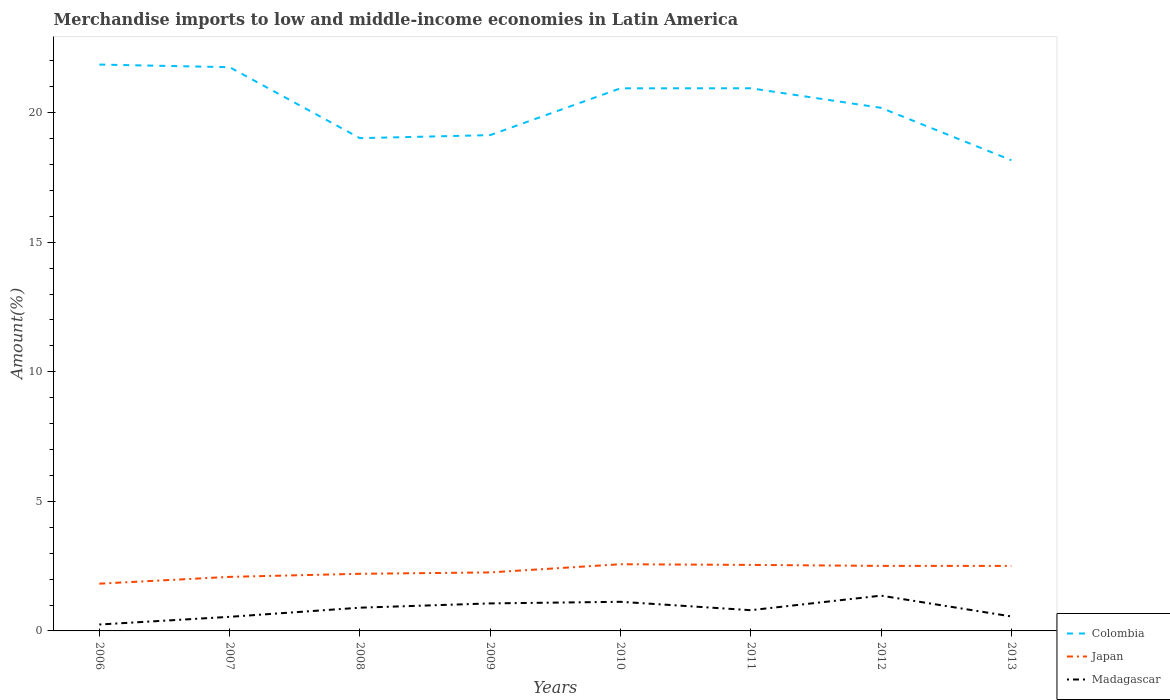Does the line corresponding to Japan intersect with the line corresponding to Madagascar?
Your response must be concise. No. Across all years, what is the maximum percentage of amount earned from merchandise imports in Japan?
Your answer should be compact. 1.82. In which year was the percentage of amount earned from merchandise imports in Colombia maximum?
Make the answer very short. 2013. What is the total percentage of amount earned from merchandise imports in Japan in the graph?
Provide a short and direct response. -0.38. What is the difference between the highest and the second highest percentage of amount earned from merchandise imports in Colombia?
Ensure brevity in your answer.  3.69. Is the percentage of amount earned from merchandise imports in Madagascar strictly greater than the percentage of amount earned from merchandise imports in Japan over the years?
Ensure brevity in your answer.  Yes. How many years are there in the graph?
Provide a short and direct response. 8. Does the graph contain any zero values?
Give a very brief answer. No. Does the graph contain grids?
Give a very brief answer. No. Where does the legend appear in the graph?
Give a very brief answer. Bottom right. How many legend labels are there?
Provide a short and direct response. 3. What is the title of the graph?
Your response must be concise. Merchandise imports to low and middle-income economies in Latin America. What is the label or title of the Y-axis?
Provide a succinct answer. Amount(%). What is the Amount(%) of Colombia in 2006?
Your response must be concise. 21.86. What is the Amount(%) of Japan in 2006?
Your answer should be very brief. 1.82. What is the Amount(%) in Madagascar in 2006?
Provide a short and direct response. 0.25. What is the Amount(%) of Colombia in 2007?
Your response must be concise. 21.76. What is the Amount(%) in Japan in 2007?
Provide a short and direct response. 2.09. What is the Amount(%) of Madagascar in 2007?
Offer a terse response. 0.54. What is the Amount(%) in Colombia in 2008?
Offer a terse response. 19.02. What is the Amount(%) in Japan in 2008?
Provide a succinct answer. 2.21. What is the Amount(%) in Madagascar in 2008?
Your answer should be very brief. 0.9. What is the Amount(%) of Colombia in 2009?
Provide a short and direct response. 19.14. What is the Amount(%) in Japan in 2009?
Offer a very short reply. 2.26. What is the Amount(%) in Madagascar in 2009?
Provide a short and direct response. 1.06. What is the Amount(%) of Colombia in 2010?
Make the answer very short. 20.94. What is the Amount(%) of Japan in 2010?
Keep it short and to the point. 2.57. What is the Amount(%) in Madagascar in 2010?
Offer a very short reply. 1.12. What is the Amount(%) in Colombia in 2011?
Offer a terse response. 20.94. What is the Amount(%) in Japan in 2011?
Your response must be concise. 2.55. What is the Amount(%) in Madagascar in 2011?
Give a very brief answer. 0.8. What is the Amount(%) of Colombia in 2012?
Your answer should be compact. 20.19. What is the Amount(%) in Japan in 2012?
Provide a short and direct response. 2.51. What is the Amount(%) in Madagascar in 2012?
Your response must be concise. 1.36. What is the Amount(%) of Colombia in 2013?
Your answer should be very brief. 18.17. What is the Amount(%) in Japan in 2013?
Keep it short and to the point. 2.51. What is the Amount(%) in Madagascar in 2013?
Offer a very short reply. 0.56. Across all years, what is the maximum Amount(%) in Colombia?
Offer a terse response. 21.86. Across all years, what is the maximum Amount(%) in Japan?
Give a very brief answer. 2.57. Across all years, what is the maximum Amount(%) of Madagascar?
Provide a short and direct response. 1.36. Across all years, what is the minimum Amount(%) in Colombia?
Make the answer very short. 18.17. Across all years, what is the minimum Amount(%) of Japan?
Make the answer very short. 1.82. Across all years, what is the minimum Amount(%) of Madagascar?
Ensure brevity in your answer.  0.25. What is the total Amount(%) in Colombia in the graph?
Your answer should be very brief. 162.01. What is the total Amount(%) in Japan in the graph?
Ensure brevity in your answer.  18.51. What is the total Amount(%) of Madagascar in the graph?
Give a very brief answer. 6.59. What is the difference between the Amount(%) of Colombia in 2006 and that in 2007?
Provide a succinct answer. 0.1. What is the difference between the Amount(%) of Japan in 2006 and that in 2007?
Offer a very short reply. -0.26. What is the difference between the Amount(%) of Madagascar in 2006 and that in 2007?
Offer a very short reply. -0.3. What is the difference between the Amount(%) in Colombia in 2006 and that in 2008?
Offer a terse response. 2.84. What is the difference between the Amount(%) in Japan in 2006 and that in 2008?
Offer a very short reply. -0.38. What is the difference between the Amount(%) of Madagascar in 2006 and that in 2008?
Your response must be concise. -0.65. What is the difference between the Amount(%) in Colombia in 2006 and that in 2009?
Give a very brief answer. 2.72. What is the difference between the Amount(%) of Japan in 2006 and that in 2009?
Give a very brief answer. -0.43. What is the difference between the Amount(%) of Madagascar in 2006 and that in 2009?
Offer a terse response. -0.81. What is the difference between the Amount(%) in Colombia in 2006 and that in 2010?
Your response must be concise. 0.92. What is the difference between the Amount(%) in Japan in 2006 and that in 2010?
Give a very brief answer. -0.75. What is the difference between the Amount(%) in Madagascar in 2006 and that in 2010?
Provide a short and direct response. -0.88. What is the difference between the Amount(%) of Colombia in 2006 and that in 2011?
Your answer should be very brief. 0.91. What is the difference between the Amount(%) in Japan in 2006 and that in 2011?
Your answer should be compact. -0.72. What is the difference between the Amount(%) in Madagascar in 2006 and that in 2011?
Provide a short and direct response. -0.55. What is the difference between the Amount(%) of Colombia in 2006 and that in 2012?
Offer a very short reply. 1.67. What is the difference between the Amount(%) of Japan in 2006 and that in 2012?
Offer a terse response. -0.69. What is the difference between the Amount(%) of Madagascar in 2006 and that in 2012?
Your answer should be very brief. -1.11. What is the difference between the Amount(%) in Colombia in 2006 and that in 2013?
Your answer should be compact. 3.69. What is the difference between the Amount(%) of Japan in 2006 and that in 2013?
Your response must be concise. -0.69. What is the difference between the Amount(%) in Madagascar in 2006 and that in 2013?
Offer a very short reply. -0.31. What is the difference between the Amount(%) of Colombia in 2007 and that in 2008?
Your answer should be very brief. 2.74. What is the difference between the Amount(%) of Japan in 2007 and that in 2008?
Your answer should be compact. -0.12. What is the difference between the Amount(%) in Madagascar in 2007 and that in 2008?
Make the answer very short. -0.35. What is the difference between the Amount(%) of Colombia in 2007 and that in 2009?
Your response must be concise. 2.62. What is the difference between the Amount(%) of Japan in 2007 and that in 2009?
Your answer should be compact. -0.17. What is the difference between the Amount(%) of Madagascar in 2007 and that in 2009?
Your answer should be very brief. -0.52. What is the difference between the Amount(%) in Colombia in 2007 and that in 2010?
Offer a terse response. 0.82. What is the difference between the Amount(%) of Japan in 2007 and that in 2010?
Keep it short and to the point. -0.49. What is the difference between the Amount(%) in Madagascar in 2007 and that in 2010?
Provide a succinct answer. -0.58. What is the difference between the Amount(%) of Colombia in 2007 and that in 2011?
Give a very brief answer. 0.81. What is the difference between the Amount(%) of Japan in 2007 and that in 2011?
Give a very brief answer. -0.46. What is the difference between the Amount(%) in Madagascar in 2007 and that in 2011?
Make the answer very short. -0.26. What is the difference between the Amount(%) in Colombia in 2007 and that in 2012?
Ensure brevity in your answer.  1.57. What is the difference between the Amount(%) in Japan in 2007 and that in 2012?
Your answer should be very brief. -0.42. What is the difference between the Amount(%) of Madagascar in 2007 and that in 2012?
Offer a terse response. -0.82. What is the difference between the Amount(%) in Colombia in 2007 and that in 2013?
Ensure brevity in your answer.  3.59. What is the difference between the Amount(%) in Japan in 2007 and that in 2013?
Offer a very short reply. -0.42. What is the difference between the Amount(%) of Madagascar in 2007 and that in 2013?
Provide a short and direct response. -0.02. What is the difference between the Amount(%) in Colombia in 2008 and that in 2009?
Offer a very short reply. -0.12. What is the difference between the Amount(%) in Japan in 2008 and that in 2009?
Make the answer very short. -0.05. What is the difference between the Amount(%) of Madagascar in 2008 and that in 2009?
Keep it short and to the point. -0.17. What is the difference between the Amount(%) of Colombia in 2008 and that in 2010?
Your answer should be very brief. -1.92. What is the difference between the Amount(%) of Japan in 2008 and that in 2010?
Make the answer very short. -0.37. What is the difference between the Amount(%) of Madagascar in 2008 and that in 2010?
Offer a terse response. -0.23. What is the difference between the Amount(%) of Colombia in 2008 and that in 2011?
Ensure brevity in your answer.  -1.93. What is the difference between the Amount(%) in Japan in 2008 and that in 2011?
Ensure brevity in your answer.  -0.34. What is the difference between the Amount(%) of Madagascar in 2008 and that in 2011?
Your response must be concise. 0.1. What is the difference between the Amount(%) in Colombia in 2008 and that in 2012?
Your answer should be compact. -1.17. What is the difference between the Amount(%) in Japan in 2008 and that in 2012?
Ensure brevity in your answer.  -0.3. What is the difference between the Amount(%) in Madagascar in 2008 and that in 2012?
Your answer should be compact. -0.46. What is the difference between the Amount(%) in Colombia in 2008 and that in 2013?
Make the answer very short. 0.85. What is the difference between the Amount(%) in Japan in 2008 and that in 2013?
Provide a succinct answer. -0.3. What is the difference between the Amount(%) of Madagascar in 2008 and that in 2013?
Provide a short and direct response. 0.34. What is the difference between the Amount(%) in Colombia in 2009 and that in 2010?
Offer a very short reply. -1.81. What is the difference between the Amount(%) of Japan in 2009 and that in 2010?
Your answer should be compact. -0.32. What is the difference between the Amount(%) of Madagascar in 2009 and that in 2010?
Provide a short and direct response. -0.06. What is the difference between the Amount(%) of Colombia in 2009 and that in 2011?
Offer a terse response. -1.81. What is the difference between the Amount(%) in Japan in 2009 and that in 2011?
Ensure brevity in your answer.  -0.29. What is the difference between the Amount(%) of Madagascar in 2009 and that in 2011?
Your answer should be compact. 0.26. What is the difference between the Amount(%) in Colombia in 2009 and that in 2012?
Make the answer very short. -1.05. What is the difference between the Amount(%) in Japan in 2009 and that in 2012?
Keep it short and to the point. -0.25. What is the difference between the Amount(%) of Madagascar in 2009 and that in 2012?
Your response must be concise. -0.3. What is the difference between the Amount(%) in Japan in 2009 and that in 2013?
Offer a very short reply. -0.25. What is the difference between the Amount(%) of Madagascar in 2009 and that in 2013?
Ensure brevity in your answer.  0.5. What is the difference between the Amount(%) of Colombia in 2010 and that in 2011?
Your response must be concise. -0. What is the difference between the Amount(%) of Japan in 2010 and that in 2011?
Give a very brief answer. 0.03. What is the difference between the Amount(%) in Madagascar in 2010 and that in 2011?
Your answer should be very brief. 0.32. What is the difference between the Amount(%) of Colombia in 2010 and that in 2012?
Provide a succinct answer. 0.75. What is the difference between the Amount(%) of Japan in 2010 and that in 2012?
Ensure brevity in your answer.  0.06. What is the difference between the Amount(%) in Madagascar in 2010 and that in 2012?
Give a very brief answer. -0.24. What is the difference between the Amount(%) of Colombia in 2010 and that in 2013?
Ensure brevity in your answer.  2.78. What is the difference between the Amount(%) of Japan in 2010 and that in 2013?
Your response must be concise. 0.06. What is the difference between the Amount(%) of Madagascar in 2010 and that in 2013?
Your answer should be very brief. 0.56. What is the difference between the Amount(%) of Colombia in 2011 and that in 2012?
Make the answer very short. 0.75. What is the difference between the Amount(%) in Japan in 2011 and that in 2012?
Give a very brief answer. 0.04. What is the difference between the Amount(%) in Madagascar in 2011 and that in 2012?
Provide a short and direct response. -0.56. What is the difference between the Amount(%) in Colombia in 2011 and that in 2013?
Ensure brevity in your answer.  2.78. What is the difference between the Amount(%) in Japan in 2011 and that in 2013?
Provide a short and direct response. 0.04. What is the difference between the Amount(%) in Madagascar in 2011 and that in 2013?
Provide a short and direct response. 0.24. What is the difference between the Amount(%) of Colombia in 2012 and that in 2013?
Provide a short and direct response. 2.02. What is the difference between the Amount(%) of Madagascar in 2012 and that in 2013?
Ensure brevity in your answer.  0.8. What is the difference between the Amount(%) of Colombia in 2006 and the Amount(%) of Japan in 2007?
Offer a very short reply. 19.77. What is the difference between the Amount(%) of Colombia in 2006 and the Amount(%) of Madagascar in 2007?
Give a very brief answer. 21.31. What is the difference between the Amount(%) of Japan in 2006 and the Amount(%) of Madagascar in 2007?
Keep it short and to the point. 1.28. What is the difference between the Amount(%) in Colombia in 2006 and the Amount(%) in Japan in 2008?
Make the answer very short. 19.65. What is the difference between the Amount(%) of Colombia in 2006 and the Amount(%) of Madagascar in 2008?
Provide a short and direct response. 20.96. What is the difference between the Amount(%) in Japan in 2006 and the Amount(%) in Madagascar in 2008?
Keep it short and to the point. 0.93. What is the difference between the Amount(%) of Colombia in 2006 and the Amount(%) of Japan in 2009?
Provide a short and direct response. 19.6. What is the difference between the Amount(%) of Colombia in 2006 and the Amount(%) of Madagascar in 2009?
Offer a terse response. 20.8. What is the difference between the Amount(%) of Japan in 2006 and the Amount(%) of Madagascar in 2009?
Your answer should be very brief. 0.76. What is the difference between the Amount(%) in Colombia in 2006 and the Amount(%) in Japan in 2010?
Keep it short and to the point. 19.28. What is the difference between the Amount(%) in Colombia in 2006 and the Amount(%) in Madagascar in 2010?
Make the answer very short. 20.73. What is the difference between the Amount(%) of Japan in 2006 and the Amount(%) of Madagascar in 2010?
Provide a succinct answer. 0.7. What is the difference between the Amount(%) in Colombia in 2006 and the Amount(%) in Japan in 2011?
Your answer should be very brief. 19.31. What is the difference between the Amount(%) of Colombia in 2006 and the Amount(%) of Madagascar in 2011?
Offer a terse response. 21.06. What is the difference between the Amount(%) of Japan in 2006 and the Amount(%) of Madagascar in 2011?
Your answer should be very brief. 1.02. What is the difference between the Amount(%) in Colombia in 2006 and the Amount(%) in Japan in 2012?
Your answer should be very brief. 19.35. What is the difference between the Amount(%) in Colombia in 2006 and the Amount(%) in Madagascar in 2012?
Offer a very short reply. 20.5. What is the difference between the Amount(%) in Japan in 2006 and the Amount(%) in Madagascar in 2012?
Make the answer very short. 0.46. What is the difference between the Amount(%) of Colombia in 2006 and the Amount(%) of Japan in 2013?
Give a very brief answer. 19.35. What is the difference between the Amount(%) in Colombia in 2006 and the Amount(%) in Madagascar in 2013?
Your answer should be very brief. 21.3. What is the difference between the Amount(%) of Japan in 2006 and the Amount(%) of Madagascar in 2013?
Provide a short and direct response. 1.26. What is the difference between the Amount(%) in Colombia in 2007 and the Amount(%) in Japan in 2008?
Your response must be concise. 19.55. What is the difference between the Amount(%) of Colombia in 2007 and the Amount(%) of Madagascar in 2008?
Provide a short and direct response. 20.86. What is the difference between the Amount(%) in Japan in 2007 and the Amount(%) in Madagascar in 2008?
Offer a terse response. 1.19. What is the difference between the Amount(%) of Colombia in 2007 and the Amount(%) of Japan in 2009?
Give a very brief answer. 19.5. What is the difference between the Amount(%) of Colombia in 2007 and the Amount(%) of Madagascar in 2009?
Ensure brevity in your answer.  20.7. What is the difference between the Amount(%) of Japan in 2007 and the Amount(%) of Madagascar in 2009?
Your response must be concise. 1.02. What is the difference between the Amount(%) in Colombia in 2007 and the Amount(%) in Japan in 2010?
Keep it short and to the point. 19.18. What is the difference between the Amount(%) in Colombia in 2007 and the Amount(%) in Madagascar in 2010?
Offer a terse response. 20.63. What is the difference between the Amount(%) of Japan in 2007 and the Amount(%) of Madagascar in 2010?
Offer a very short reply. 0.96. What is the difference between the Amount(%) of Colombia in 2007 and the Amount(%) of Japan in 2011?
Ensure brevity in your answer.  19.21. What is the difference between the Amount(%) in Colombia in 2007 and the Amount(%) in Madagascar in 2011?
Your response must be concise. 20.96. What is the difference between the Amount(%) of Japan in 2007 and the Amount(%) of Madagascar in 2011?
Keep it short and to the point. 1.29. What is the difference between the Amount(%) in Colombia in 2007 and the Amount(%) in Japan in 2012?
Give a very brief answer. 19.25. What is the difference between the Amount(%) of Colombia in 2007 and the Amount(%) of Madagascar in 2012?
Your answer should be very brief. 20.4. What is the difference between the Amount(%) in Japan in 2007 and the Amount(%) in Madagascar in 2012?
Your response must be concise. 0.72. What is the difference between the Amount(%) of Colombia in 2007 and the Amount(%) of Japan in 2013?
Your answer should be very brief. 19.25. What is the difference between the Amount(%) of Colombia in 2007 and the Amount(%) of Madagascar in 2013?
Your answer should be compact. 21.2. What is the difference between the Amount(%) in Japan in 2007 and the Amount(%) in Madagascar in 2013?
Keep it short and to the point. 1.53. What is the difference between the Amount(%) of Colombia in 2008 and the Amount(%) of Japan in 2009?
Your answer should be compact. 16.76. What is the difference between the Amount(%) of Colombia in 2008 and the Amount(%) of Madagascar in 2009?
Offer a very short reply. 17.96. What is the difference between the Amount(%) of Japan in 2008 and the Amount(%) of Madagascar in 2009?
Give a very brief answer. 1.14. What is the difference between the Amount(%) of Colombia in 2008 and the Amount(%) of Japan in 2010?
Ensure brevity in your answer.  16.44. What is the difference between the Amount(%) of Colombia in 2008 and the Amount(%) of Madagascar in 2010?
Offer a terse response. 17.89. What is the difference between the Amount(%) in Japan in 2008 and the Amount(%) in Madagascar in 2010?
Your answer should be very brief. 1.08. What is the difference between the Amount(%) of Colombia in 2008 and the Amount(%) of Japan in 2011?
Provide a short and direct response. 16.47. What is the difference between the Amount(%) in Colombia in 2008 and the Amount(%) in Madagascar in 2011?
Ensure brevity in your answer.  18.22. What is the difference between the Amount(%) in Japan in 2008 and the Amount(%) in Madagascar in 2011?
Ensure brevity in your answer.  1.41. What is the difference between the Amount(%) of Colombia in 2008 and the Amount(%) of Japan in 2012?
Offer a very short reply. 16.51. What is the difference between the Amount(%) in Colombia in 2008 and the Amount(%) in Madagascar in 2012?
Your response must be concise. 17.66. What is the difference between the Amount(%) in Japan in 2008 and the Amount(%) in Madagascar in 2012?
Your response must be concise. 0.84. What is the difference between the Amount(%) of Colombia in 2008 and the Amount(%) of Japan in 2013?
Offer a very short reply. 16.51. What is the difference between the Amount(%) in Colombia in 2008 and the Amount(%) in Madagascar in 2013?
Your answer should be very brief. 18.46. What is the difference between the Amount(%) of Japan in 2008 and the Amount(%) of Madagascar in 2013?
Keep it short and to the point. 1.65. What is the difference between the Amount(%) in Colombia in 2009 and the Amount(%) in Japan in 2010?
Your response must be concise. 16.56. What is the difference between the Amount(%) in Colombia in 2009 and the Amount(%) in Madagascar in 2010?
Make the answer very short. 18.01. What is the difference between the Amount(%) of Japan in 2009 and the Amount(%) of Madagascar in 2010?
Ensure brevity in your answer.  1.13. What is the difference between the Amount(%) of Colombia in 2009 and the Amount(%) of Japan in 2011?
Make the answer very short. 16.59. What is the difference between the Amount(%) in Colombia in 2009 and the Amount(%) in Madagascar in 2011?
Make the answer very short. 18.34. What is the difference between the Amount(%) of Japan in 2009 and the Amount(%) of Madagascar in 2011?
Provide a succinct answer. 1.46. What is the difference between the Amount(%) in Colombia in 2009 and the Amount(%) in Japan in 2012?
Your response must be concise. 16.63. What is the difference between the Amount(%) of Colombia in 2009 and the Amount(%) of Madagascar in 2012?
Provide a succinct answer. 17.77. What is the difference between the Amount(%) of Japan in 2009 and the Amount(%) of Madagascar in 2012?
Your answer should be very brief. 0.9. What is the difference between the Amount(%) in Colombia in 2009 and the Amount(%) in Japan in 2013?
Provide a succinct answer. 16.63. What is the difference between the Amount(%) in Colombia in 2009 and the Amount(%) in Madagascar in 2013?
Keep it short and to the point. 18.58. What is the difference between the Amount(%) of Japan in 2009 and the Amount(%) of Madagascar in 2013?
Offer a terse response. 1.7. What is the difference between the Amount(%) of Colombia in 2010 and the Amount(%) of Japan in 2011?
Offer a very short reply. 18.39. What is the difference between the Amount(%) in Colombia in 2010 and the Amount(%) in Madagascar in 2011?
Make the answer very short. 20.14. What is the difference between the Amount(%) in Japan in 2010 and the Amount(%) in Madagascar in 2011?
Make the answer very short. 1.77. What is the difference between the Amount(%) of Colombia in 2010 and the Amount(%) of Japan in 2012?
Ensure brevity in your answer.  18.43. What is the difference between the Amount(%) of Colombia in 2010 and the Amount(%) of Madagascar in 2012?
Keep it short and to the point. 19.58. What is the difference between the Amount(%) in Japan in 2010 and the Amount(%) in Madagascar in 2012?
Provide a short and direct response. 1.21. What is the difference between the Amount(%) in Colombia in 2010 and the Amount(%) in Japan in 2013?
Provide a succinct answer. 18.43. What is the difference between the Amount(%) in Colombia in 2010 and the Amount(%) in Madagascar in 2013?
Offer a very short reply. 20.38. What is the difference between the Amount(%) of Japan in 2010 and the Amount(%) of Madagascar in 2013?
Your response must be concise. 2.01. What is the difference between the Amount(%) of Colombia in 2011 and the Amount(%) of Japan in 2012?
Your answer should be very brief. 18.43. What is the difference between the Amount(%) in Colombia in 2011 and the Amount(%) in Madagascar in 2012?
Ensure brevity in your answer.  19.58. What is the difference between the Amount(%) of Japan in 2011 and the Amount(%) of Madagascar in 2012?
Keep it short and to the point. 1.19. What is the difference between the Amount(%) in Colombia in 2011 and the Amount(%) in Japan in 2013?
Offer a very short reply. 18.43. What is the difference between the Amount(%) in Colombia in 2011 and the Amount(%) in Madagascar in 2013?
Keep it short and to the point. 20.38. What is the difference between the Amount(%) of Japan in 2011 and the Amount(%) of Madagascar in 2013?
Ensure brevity in your answer.  1.99. What is the difference between the Amount(%) in Colombia in 2012 and the Amount(%) in Japan in 2013?
Offer a terse response. 17.68. What is the difference between the Amount(%) in Colombia in 2012 and the Amount(%) in Madagascar in 2013?
Your answer should be very brief. 19.63. What is the difference between the Amount(%) of Japan in 2012 and the Amount(%) of Madagascar in 2013?
Your answer should be very brief. 1.95. What is the average Amount(%) of Colombia per year?
Make the answer very short. 20.25. What is the average Amount(%) in Japan per year?
Provide a short and direct response. 2.31. What is the average Amount(%) in Madagascar per year?
Offer a terse response. 0.82. In the year 2006, what is the difference between the Amount(%) in Colombia and Amount(%) in Japan?
Give a very brief answer. 20.03. In the year 2006, what is the difference between the Amount(%) of Colombia and Amount(%) of Madagascar?
Your response must be concise. 21.61. In the year 2006, what is the difference between the Amount(%) in Japan and Amount(%) in Madagascar?
Give a very brief answer. 1.58. In the year 2007, what is the difference between the Amount(%) in Colombia and Amount(%) in Japan?
Your response must be concise. 19.67. In the year 2007, what is the difference between the Amount(%) of Colombia and Amount(%) of Madagascar?
Make the answer very short. 21.21. In the year 2007, what is the difference between the Amount(%) of Japan and Amount(%) of Madagascar?
Your answer should be compact. 1.54. In the year 2008, what is the difference between the Amount(%) of Colombia and Amount(%) of Japan?
Provide a succinct answer. 16.81. In the year 2008, what is the difference between the Amount(%) of Colombia and Amount(%) of Madagascar?
Your response must be concise. 18.12. In the year 2008, what is the difference between the Amount(%) of Japan and Amount(%) of Madagascar?
Give a very brief answer. 1.31. In the year 2009, what is the difference between the Amount(%) of Colombia and Amount(%) of Japan?
Keep it short and to the point. 16.88. In the year 2009, what is the difference between the Amount(%) in Colombia and Amount(%) in Madagascar?
Keep it short and to the point. 18.07. In the year 2009, what is the difference between the Amount(%) of Japan and Amount(%) of Madagascar?
Your response must be concise. 1.2. In the year 2010, what is the difference between the Amount(%) in Colombia and Amount(%) in Japan?
Give a very brief answer. 18.37. In the year 2010, what is the difference between the Amount(%) in Colombia and Amount(%) in Madagascar?
Give a very brief answer. 19.82. In the year 2010, what is the difference between the Amount(%) in Japan and Amount(%) in Madagascar?
Offer a terse response. 1.45. In the year 2011, what is the difference between the Amount(%) of Colombia and Amount(%) of Japan?
Your response must be concise. 18.39. In the year 2011, what is the difference between the Amount(%) in Colombia and Amount(%) in Madagascar?
Ensure brevity in your answer.  20.14. In the year 2011, what is the difference between the Amount(%) of Japan and Amount(%) of Madagascar?
Offer a very short reply. 1.75. In the year 2012, what is the difference between the Amount(%) of Colombia and Amount(%) of Japan?
Your response must be concise. 17.68. In the year 2012, what is the difference between the Amount(%) of Colombia and Amount(%) of Madagascar?
Your answer should be very brief. 18.83. In the year 2012, what is the difference between the Amount(%) in Japan and Amount(%) in Madagascar?
Keep it short and to the point. 1.15. In the year 2013, what is the difference between the Amount(%) of Colombia and Amount(%) of Japan?
Offer a terse response. 15.66. In the year 2013, what is the difference between the Amount(%) of Colombia and Amount(%) of Madagascar?
Provide a succinct answer. 17.61. In the year 2013, what is the difference between the Amount(%) in Japan and Amount(%) in Madagascar?
Provide a short and direct response. 1.95. What is the ratio of the Amount(%) in Japan in 2006 to that in 2007?
Ensure brevity in your answer.  0.87. What is the ratio of the Amount(%) in Madagascar in 2006 to that in 2007?
Your answer should be compact. 0.46. What is the ratio of the Amount(%) of Colombia in 2006 to that in 2008?
Give a very brief answer. 1.15. What is the ratio of the Amount(%) of Japan in 2006 to that in 2008?
Provide a short and direct response. 0.83. What is the ratio of the Amount(%) in Madagascar in 2006 to that in 2008?
Offer a very short reply. 0.28. What is the ratio of the Amount(%) of Colombia in 2006 to that in 2009?
Ensure brevity in your answer.  1.14. What is the ratio of the Amount(%) of Japan in 2006 to that in 2009?
Your answer should be very brief. 0.81. What is the ratio of the Amount(%) of Madagascar in 2006 to that in 2009?
Your response must be concise. 0.23. What is the ratio of the Amount(%) in Colombia in 2006 to that in 2010?
Make the answer very short. 1.04. What is the ratio of the Amount(%) in Japan in 2006 to that in 2010?
Keep it short and to the point. 0.71. What is the ratio of the Amount(%) in Madagascar in 2006 to that in 2010?
Your answer should be very brief. 0.22. What is the ratio of the Amount(%) in Colombia in 2006 to that in 2011?
Your response must be concise. 1.04. What is the ratio of the Amount(%) in Japan in 2006 to that in 2011?
Your answer should be compact. 0.72. What is the ratio of the Amount(%) of Madagascar in 2006 to that in 2011?
Offer a very short reply. 0.31. What is the ratio of the Amount(%) of Colombia in 2006 to that in 2012?
Your response must be concise. 1.08. What is the ratio of the Amount(%) of Japan in 2006 to that in 2012?
Ensure brevity in your answer.  0.73. What is the ratio of the Amount(%) of Madagascar in 2006 to that in 2012?
Make the answer very short. 0.18. What is the ratio of the Amount(%) of Colombia in 2006 to that in 2013?
Your answer should be compact. 1.2. What is the ratio of the Amount(%) of Japan in 2006 to that in 2013?
Your answer should be very brief. 0.73. What is the ratio of the Amount(%) in Madagascar in 2006 to that in 2013?
Keep it short and to the point. 0.44. What is the ratio of the Amount(%) of Colombia in 2007 to that in 2008?
Offer a terse response. 1.14. What is the ratio of the Amount(%) of Japan in 2007 to that in 2008?
Your response must be concise. 0.95. What is the ratio of the Amount(%) of Madagascar in 2007 to that in 2008?
Your answer should be compact. 0.61. What is the ratio of the Amount(%) of Colombia in 2007 to that in 2009?
Ensure brevity in your answer.  1.14. What is the ratio of the Amount(%) in Japan in 2007 to that in 2009?
Your response must be concise. 0.92. What is the ratio of the Amount(%) of Madagascar in 2007 to that in 2009?
Your answer should be very brief. 0.51. What is the ratio of the Amount(%) in Colombia in 2007 to that in 2010?
Provide a succinct answer. 1.04. What is the ratio of the Amount(%) of Japan in 2007 to that in 2010?
Your answer should be very brief. 0.81. What is the ratio of the Amount(%) of Madagascar in 2007 to that in 2010?
Ensure brevity in your answer.  0.48. What is the ratio of the Amount(%) in Colombia in 2007 to that in 2011?
Provide a succinct answer. 1.04. What is the ratio of the Amount(%) of Japan in 2007 to that in 2011?
Ensure brevity in your answer.  0.82. What is the ratio of the Amount(%) in Madagascar in 2007 to that in 2011?
Your response must be concise. 0.68. What is the ratio of the Amount(%) in Colombia in 2007 to that in 2012?
Give a very brief answer. 1.08. What is the ratio of the Amount(%) of Japan in 2007 to that in 2012?
Provide a succinct answer. 0.83. What is the ratio of the Amount(%) of Madagascar in 2007 to that in 2012?
Offer a terse response. 0.4. What is the ratio of the Amount(%) in Colombia in 2007 to that in 2013?
Your answer should be compact. 1.2. What is the ratio of the Amount(%) of Japan in 2007 to that in 2013?
Keep it short and to the point. 0.83. What is the ratio of the Amount(%) of Madagascar in 2007 to that in 2013?
Give a very brief answer. 0.97. What is the ratio of the Amount(%) of Japan in 2008 to that in 2009?
Keep it short and to the point. 0.98. What is the ratio of the Amount(%) in Madagascar in 2008 to that in 2009?
Provide a succinct answer. 0.84. What is the ratio of the Amount(%) in Colombia in 2008 to that in 2010?
Offer a very short reply. 0.91. What is the ratio of the Amount(%) of Japan in 2008 to that in 2010?
Your answer should be compact. 0.86. What is the ratio of the Amount(%) in Madagascar in 2008 to that in 2010?
Offer a very short reply. 0.8. What is the ratio of the Amount(%) of Colombia in 2008 to that in 2011?
Ensure brevity in your answer.  0.91. What is the ratio of the Amount(%) of Japan in 2008 to that in 2011?
Offer a terse response. 0.87. What is the ratio of the Amount(%) of Madagascar in 2008 to that in 2011?
Give a very brief answer. 1.12. What is the ratio of the Amount(%) in Colombia in 2008 to that in 2012?
Your answer should be compact. 0.94. What is the ratio of the Amount(%) in Japan in 2008 to that in 2012?
Give a very brief answer. 0.88. What is the ratio of the Amount(%) of Madagascar in 2008 to that in 2012?
Your answer should be compact. 0.66. What is the ratio of the Amount(%) in Colombia in 2008 to that in 2013?
Your answer should be compact. 1.05. What is the ratio of the Amount(%) of Japan in 2008 to that in 2013?
Keep it short and to the point. 0.88. What is the ratio of the Amount(%) in Madagascar in 2008 to that in 2013?
Keep it short and to the point. 1.6. What is the ratio of the Amount(%) of Colombia in 2009 to that in 2010?
Provide a short and direct response. 0.91. What is the ratio of the Amount(%) of Japan in 2009 to that in 2010?
Provide a short and direct response. 0.88. What is the ratio of the Amount(%) of Madagascar in 2009 to that in 2010?
Offer a terse response. 0.94. What is the ratio of the Amount(%) in Colombia in 2009 to that in 2011?
Ensure brevity in your answer.  0.91. What is the ratio of the Amount(%) in Japan in 2009 to that in 2011?
Provide a short and direct response. 0.89. What is the ratio of the Amount(%) in Madagascar in 2009 to that in 2011?
Make the answer very short. 1.33. What is the ratio of the Amount(%) in Colombia in 2009 to that in 2012?
Offer a very short reply. 0.95. What is the ratio of the Amount(%) of Japan in 2009 to that in 2012?
Provide a succinct answer. 0.9. What is the ratio of the Amount(%) of Madagascar in 2009 to that in 2012?
Provide a succinct answer. 0.78. What is the ratio of the Amount(%) of Colombia in 2009 to that in 2013?
Your response must be concise. 1.05. What is the ratio of the Amount(%) in Japan in 2009 to that in 2013?
Keep it short and to the point. 0.9. What is the ratio of the Amount(%) in Madagascar in 2009 to that in 2013?
Make the answer very short. 1.9. What is the ratio of the Amount(%) in Colombia in 2010 to that in 2011?
Ensure brevity in your answer.  1. What is the ratio of the Amount(%) in Japan in 2010 to that in 2011?
Make the answer very short. 1.01. What is the ratio of the Amount(%) in Madagascar in 2010 to that in 2011?
Your response must be concise. 1.4. What is the ratio of the Amount(%) of Colombia in 2010 to that in 2012?
Give a very brief answer. 1.04. What is the ratio of the Amount(%) in Japan in 2010 to that in 2012?
Provide a short and direct response. 1.03. What is the ratio of the Amount(%) of Madagascar in 2010 to that in 2012?
Provide a succinct answer. 0.83. What is the ratio of the Amount(%) of Colombia in 2010 to that in 2013?
Provide a short and direct response. 1.15. What is the ratio of the Amount(%) of Japan in 2010 to that in 2013?
Ensure brevity in your answer.  1.03. What is the ratio of the Amount(%) in Madagascar in 2010 to that in 2013?
Keep it short and to the point. 2.01. What is the ratio of the Amount(%) in Colombia in 2011 to that in 2012?
Provide a succinct answer. 1.04. What is the ratio of the Amount(%) of Japan in 2011 to that in 2012?
Make the answer very short. 1.02. What is the ratio of the Amount(%) of Madagascar in 2011 to that in 2012?
Provide a short and direct response. 0.59. What is the ratio of the Amount(%) in Colombia in 2011 to that in 2013?
Offer a very short reply. 1.15. What is the ratio of the Amount(%) of Japan in 2011 to that in 2013?
Offer a very short reply. 1.02. What is the ratio of the Amount(%) of Madagascar in 2011 to that in 2013?
Your response must be concise. 1.43. What is the ratio of the Amount(%) of Colombia in 2012 to that in 2013?
Provide a succinct answer. 1.11. What is the ratio of the Amount(%) of Madagascar in 2012 to that in 2013?
Your answer should be compact. 2.44. What is the difference between the highest and the second highest Amount(%) in Colombia?
Offer a very short reply. 0.1. What is the difference between the highest and the second highest Amount(%) in Japan?
Your answer should be compact. 0.03. What is the difference between the highest and the second highest Amount(%) in Madagascar?
Ensure brevity in your answer.  0.24. What is the difference between the highest and the lowest Amount(%) of Colombia?
Give a very brief answer. 3.69. What is the difference between the highest and the lowest Amount(%) in Japan?
Offer a very short reply. 0.75. What is the difference between the highest and the lowest Amount(%) of Madagascar?
Provide a short and direct response. 1.11. 